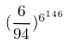Convert formula to latex. <formula><loc_0><loc_0><loc_500><loc_500>( \frac { 6 } { 9 4 } ) ^ { 6 ^ { 1 4 6 } }</formula> 